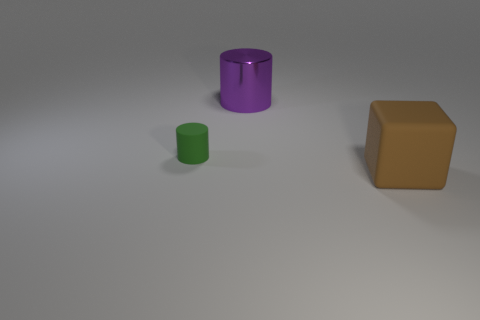The matte cylinder has what color? The matte cylinder in the image is purple. Its finish doesn't reflect light brightly, giving it a dull, even appearance characteristic of a matte surface. 